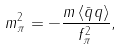<formula> <loc_0><loc_0><loc_500><loc_500>m _ { \pi } ^ { 2 } = - \frac { m \left \langle \bar { q } q \right \rangle } { f _ { \pi } ^ { 2 } \, } ,</formula> 